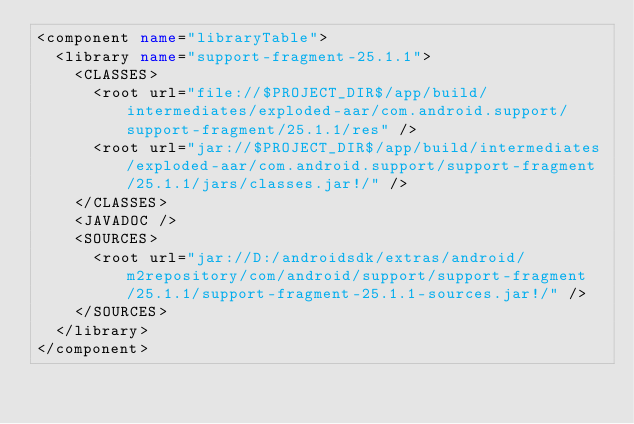<code> <loc_0><loc_0><loc_500><loc_500><_XML_><component name="libraryTable">
  <library name="support-fragment-25.1.1">
    <CLASSES>
      <root url="file://$PROJECT_DIR$/app/build/intermediates/exploded-aar/com.android.support/support-fragment/25.1.1/res" />
      <root url="jar://$PROJECT_DIR$/app/build/intermediates/exploded-aar/com.android.support/support-fragment/25.1.1/jars/classes.jar!/" />
    </CLASSES>
    <JAVADOC />
    <SOURCES>
      <root url="jar://D:/androidsdk/extras/android/m2repository/com/android/support/support-fragment/25.1.1/support-fragment-25.1.1-sources.jar!/" />
    </SOURCES>
  </library>
</component></code> 